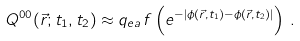Convert formula to latex. <formula><loc_0><loc_0><loc_500><loc_500>Q ^ { 0 0 } ( \vec { r } ; t _ { 1 } , t _ { 2 } ) \approx q _ { e a } \, f \left ( e ^ { - | \phi ( \vec { r } , t _ { 1 } ) - \phi ( \vec { r } , t _ { 2 } ) | } \right ) \, .</formula> 